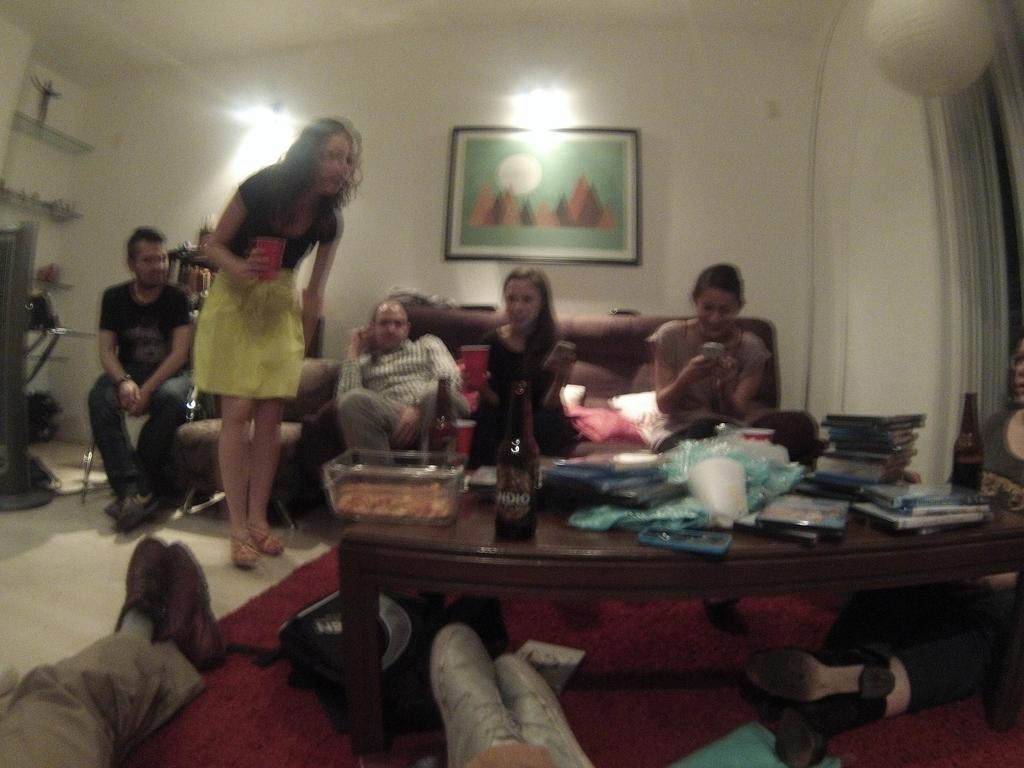In one or two sentences, can you explain what this image depicts? Here we can see a group of people sitting on couch and chairs and a woman is standing in the center with glass in her hand and there is a table in front of them having bottles of wines and books placed here and there and there is a Portrait on the wall 